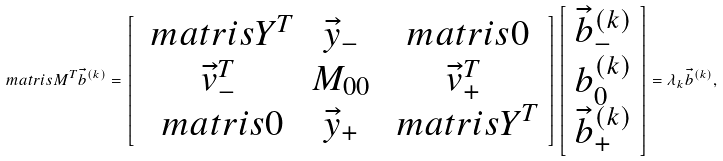<formula> <loc_0><loc_0><loc_500><loc_500>\ m a t r i s { M } ^ { T } \vec { b } ^ { ( k ) } = \left [ \begin{array} { c c c } \ m a t r i s { Y } ^ { T } & \vec { y } _ { - } & \ m a t r i s { 0 } \\ \vec { v } _ { - } ^ { T } & M _ { 0 0 } & \vec { v } _ { + } ^ { T } \\ \ m a t r i s { 0 } & \vec { y } _ { + } & \ m a t r i s { Y } ^ { T } \\ \end{array} \right ] \left [ \begin{array} { l } \vec { b } _ { - } ^ { ( k ) } \\ b _ { 0 } ^ { ( k ) } \\ \vec { b } _ { + } ^ { ( k ) } \end{array} \right ] = \lambda _ { k } \vec { b } ^ { ( k ) } ,</formula> 